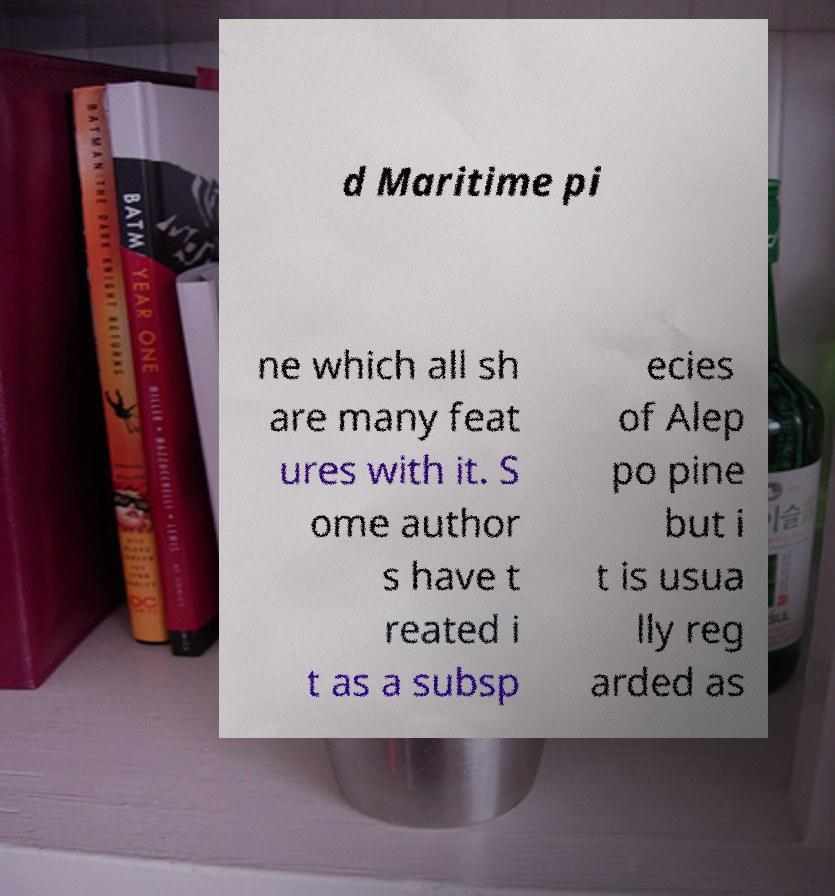Please read and relay the text visible in this image. What does it say? d Maritime pi ne which all sh are many feat ures with it. S ome author s have t reated i t as a subsp ecies of Alep po pine but i t is usua lly reg arded as 